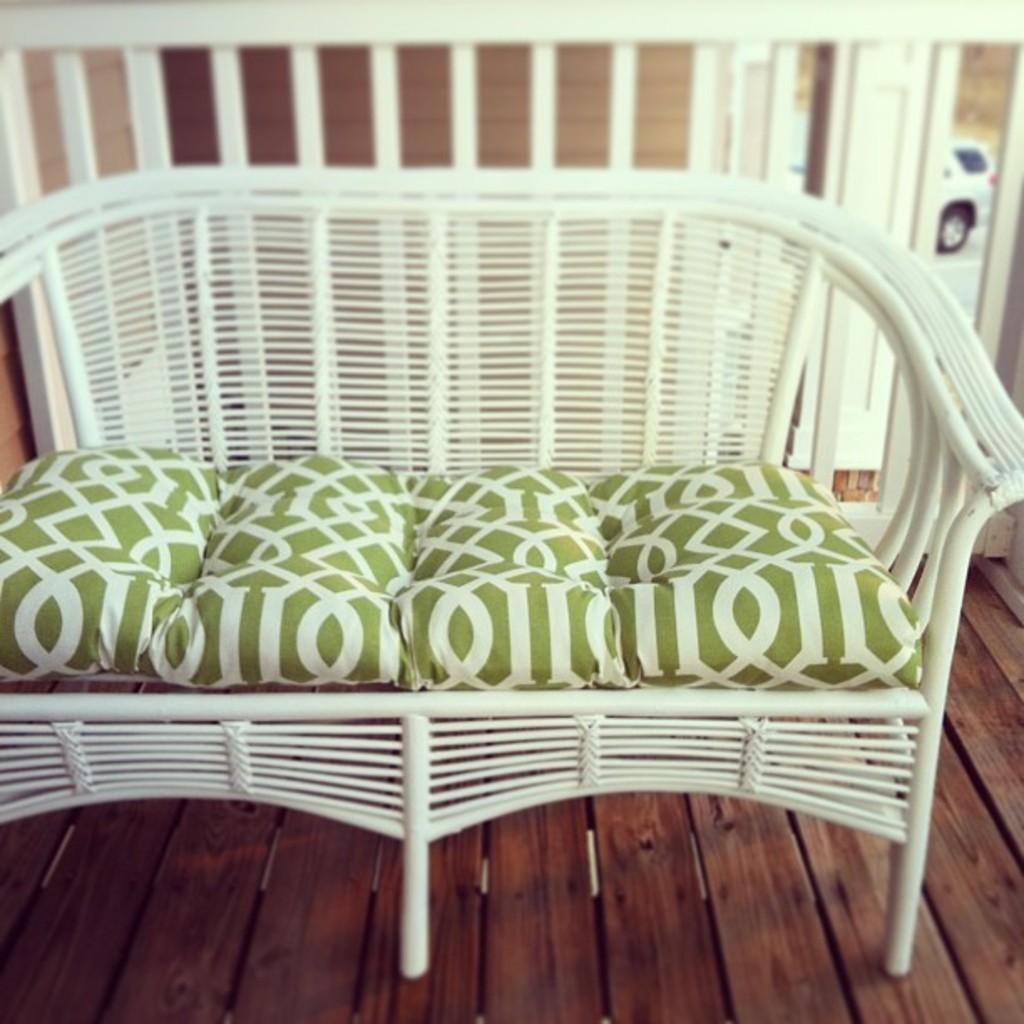Describe this image in one or two sentences. In this image we can see a sofa on the wooden surface, there are pillows, at the back there is a fencing, there is a car travelling on the road. 